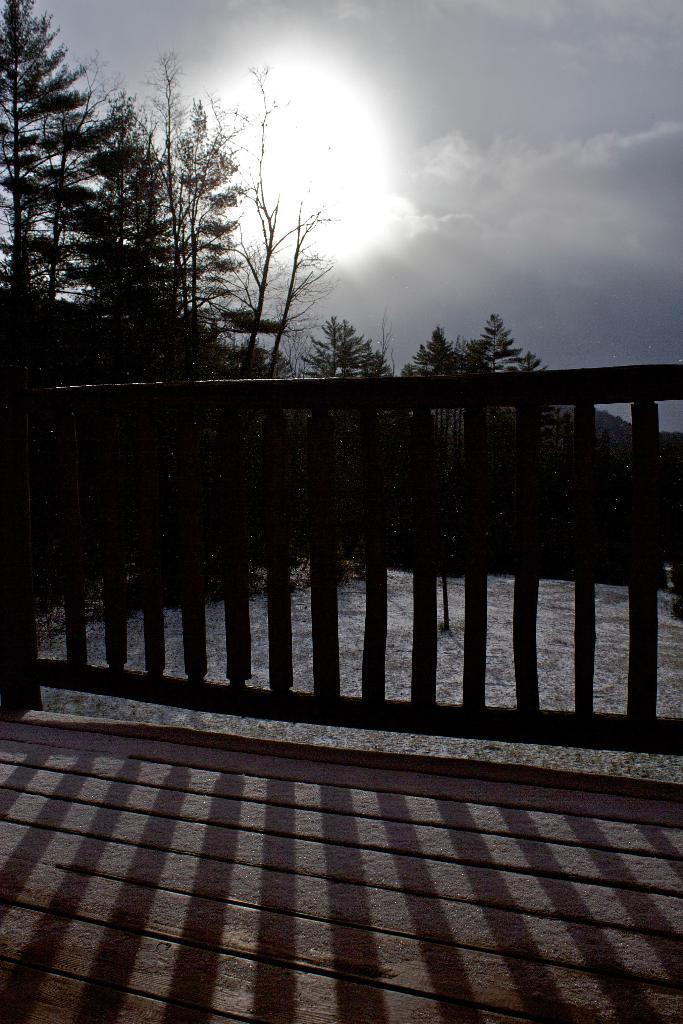What type of vegetation can be seen in the image? There are trees in the image. What type of structure is present in the image? There is a fence in the image. What is visible in the sky in the image? Moonlight is visible in the sky in the image. Can you see an arch made of lace in the image? There is no arch or lace present in the image. Is there a parcel being delivered by the moonlight in the image? There is no parcel or delivery depicted in the image. 